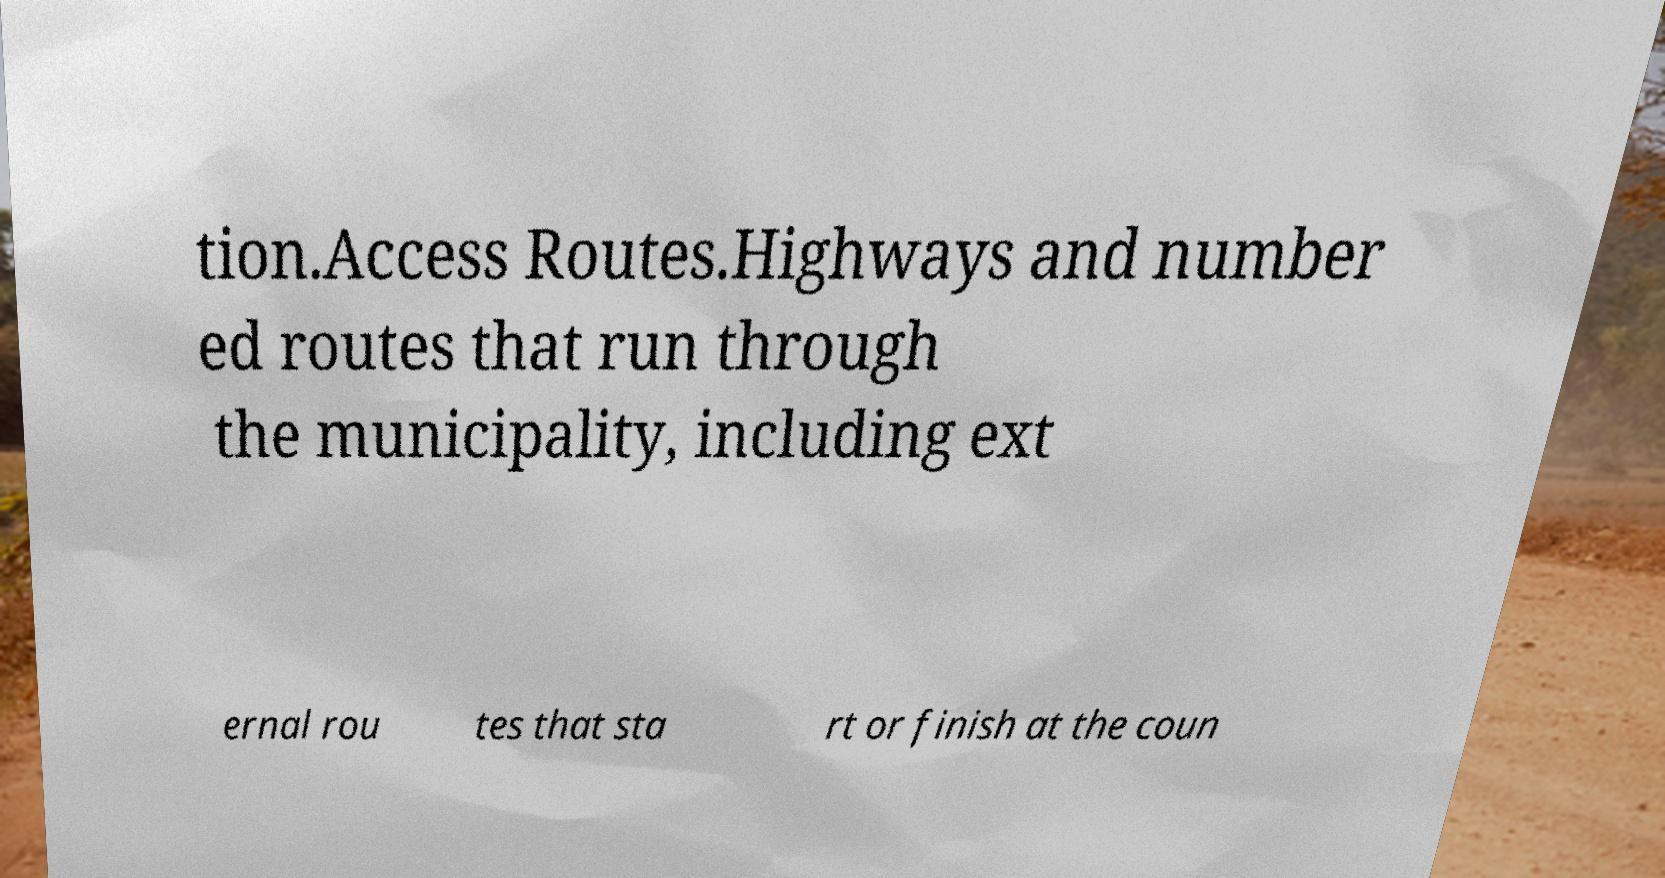Could you assist in decoding the text presented in this image and type it out clearly? tion.Access Routes.Highways and number ed routes that run through the municipality, including ext ernal rou tes that sta rt or finish at the coun 